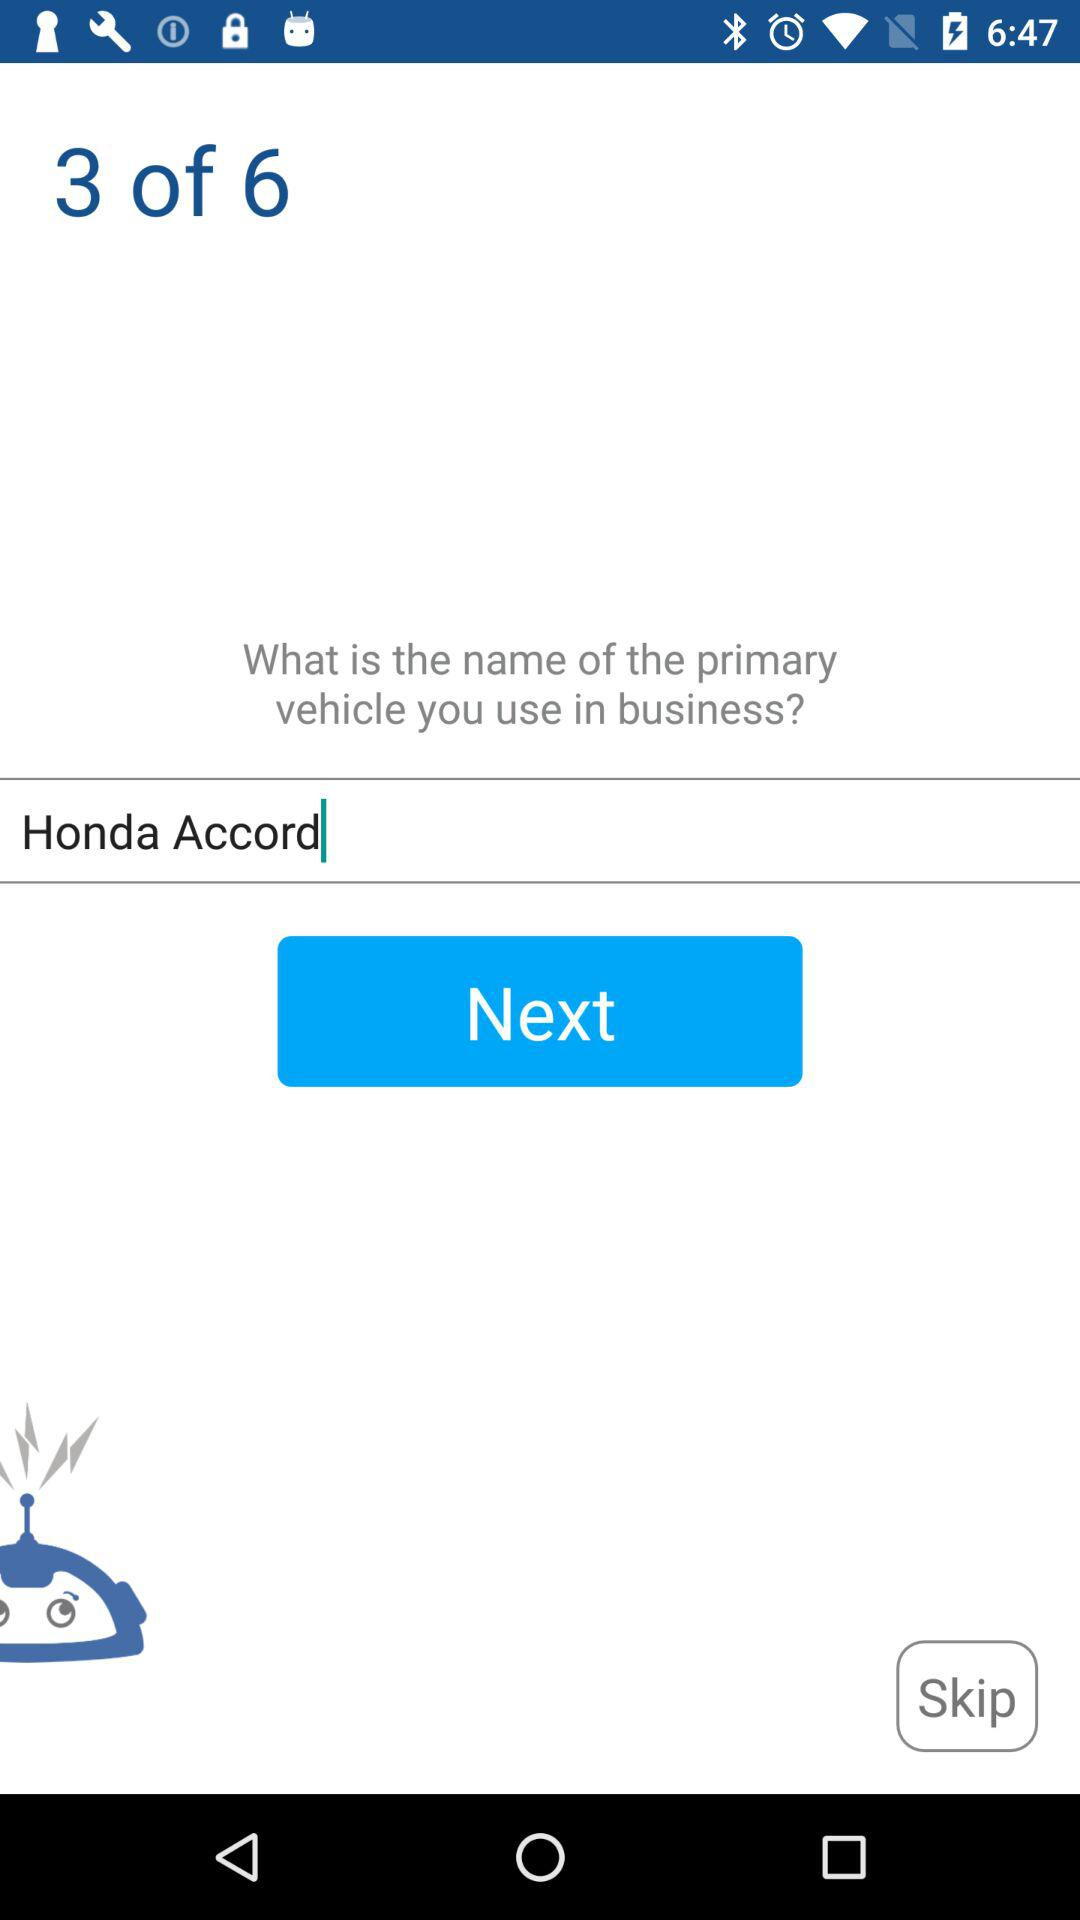How many pages are there in total? There are a total of 6 pages. 